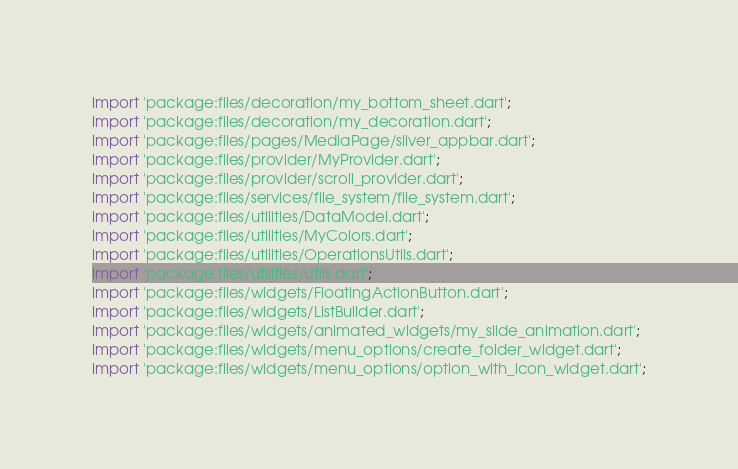Convert code to text. <code><loc_0><loc_0><loc_500><loc_500><_Dart_>import 'package:files/decoration/my_bottom_sheet.dart';
import 'package:files/decoration/my_decoration.dart';
import 'package:files/pages/MediaPage/sliver_appbar.dart';
import 'package:files/provider/MyProvider.dart';
import 'package:files/provider/scroll_provider.dart';
import 'package:files/services/file_system/file_system.dart';
import 'package:files/utilities/DataModel.dart';
import 'package:files/utilities/MyColors.dart';
import 'package:files/utilities/OperationsUtils.dart';
import 'package:files/utilities/Utils.dart';
import 'package:files/widgets/FloatingActionButton.dart';
import 'package:files/widgets/ListBuilder.dart';
import 'package:files/widgets/animated_widgets/my_slide_animation.dart';
import 'package:files/widgets/menu_options/create_folder_widget.dart';
import 'package:files/widgets/menu_options/option_with_icon_widget.dart';</code> 